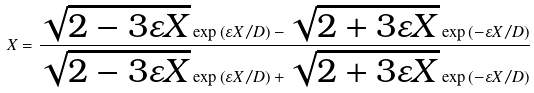<formula> <loc_0><loc_0><loc_500><loc_500>X = \frac { \sqrt { 2 - 3 \varepsilon X } \exp \left ( \varepsilon X / D \right ) - \sqrt { 2 + 3 \varepsilon X } \exp \left ( - \varepsilon X / D \right ) } { \sqrt { 2 - 3 \varepsilon X } \exp \left ( \varepsilon X / D \right ) + \sqrt { 2 + 3 \varepsilon X } \exp \left ( - \varepsilon X / D \right ) }</formula> 